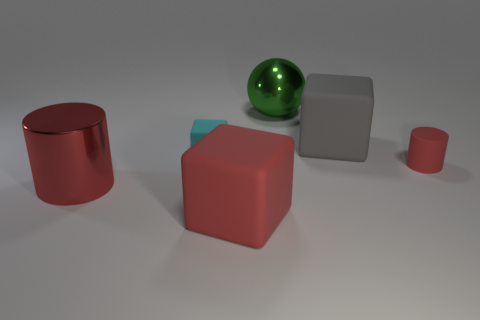How many rubber cylinders are there?
Offer a very short reply. 1. Is the large red cube made of the same material as the red cylinder to the right of the ball?
Keep it short and to the point. Yes. There is a matte cube to the right of the big green thing; does it have the same color as the metal sphere?
Give a very brief answer. No. The red thing that is to the right of the red metal thing and on the left side of the green metal object is made of what material?
Your answer should be compact. Rubber. What size is the metal cylinder?
Your answer should be compact. Large. Do the large ball and the large block to the left of the big gray rubber object have the same color?
Offer a terse response. No. How many other things are there of the same color as the tiny matte cube?
Give a very brief answer. 0. Do the green thing that is behind the large gray block and the cylinder left of the cyan cube have the same size?
Ensure brevity in your answer.  Yes. There is a metal thing that is in front of the green metal ball; what color is it?
Your response must be concise. Red. Are there fewer red objects left of the small red matte thing than big gray rubber cubes?
Make the answer very short. No. 